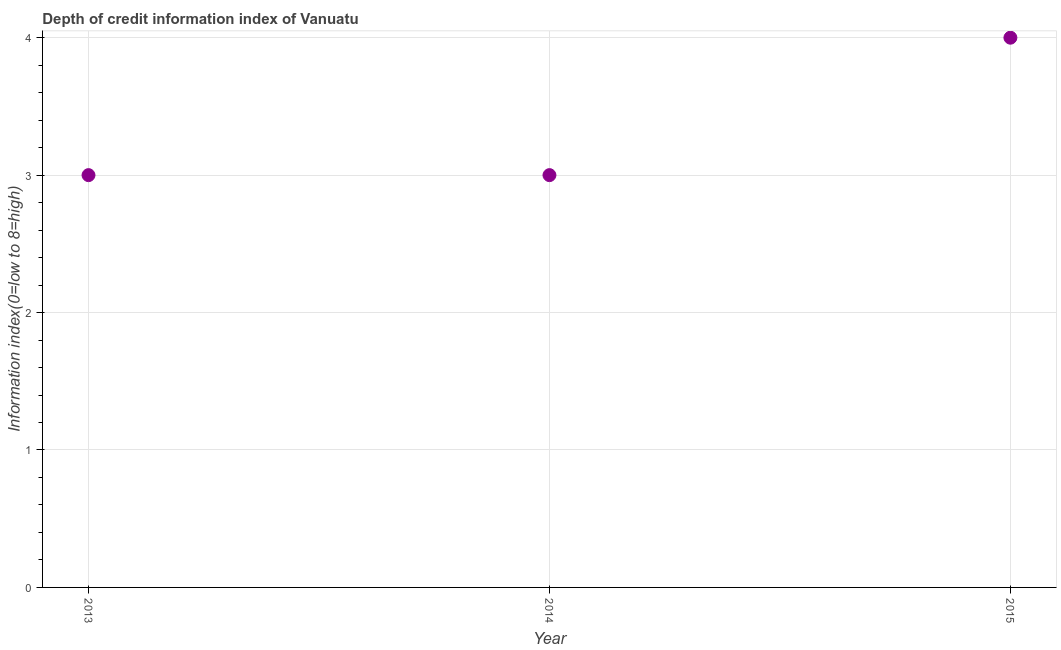What is the depth of credit information index in 2013?
Make the answer very short. 3. Across all years, what is the maximum depth of credit information index?
Make the answer very short. 4. Across all years, what is the minimum depth of credit information index?
Give a very brief answer. 3. In which year was the depth of credit information index maximum?
Make the answer very short. 2015. What is the sum of the depth of credit information index?
Give a very brief answer. 10. What is the difference between the depth of credit information index in 2014 and 2015?
Your answer should be very brief. -1. What is the average depth of credit information index per year?
Offer a terse response. 3.33. What is the median depth of credit information index?
Your response must be concise. 3. Do a majority of the years between 2014 and 2013 (inclusive) have depth of credit information index greater than 2.4 ?
Your response must be concise. No. What is the ratio of the depth of credit information index in 2014 to that in 2015?
Offer a very short reply. 0.75. Is the depth of credit information index in 2013 less than that in 2014?
Offer a terse response. No. Is the difference between the depth of credit information index in 2013 and 2015 greater than the difference between any two years?
Provide a succinct answer. Yes. What is the difference between the highest and the second highest depth of credit information index?
Offer a terse response. 1. What is the difference between the highest and the lowest depth of credit information index?
Make the answer very short. 1. Does the depth of credit information index monotonically increase over the years?
Your answer should be very brief. No. Does the graph contain grids?
Provide a succinct answer. Yes. What is the title of the graph?
Ensure brevity in your answer.  Depth of credit information index of Vanuatu. What is the label or title of the X-axis?
Offer a terse response. Year. What is the label or title of the Y-axis?
Make the answer very short. Information index(0=low to 8=high). What is the Information index(0=low to 8=high) in 2013?
Give a very brief answer. 3. What is the difference between the Information index(0=low to 8=high) in 2013 and 2014?
Keep it short and to the point. 0. What is the difference between the Information index(0=low to 8=high) in 2013 and 2015?
Your response must be concise. -1. 